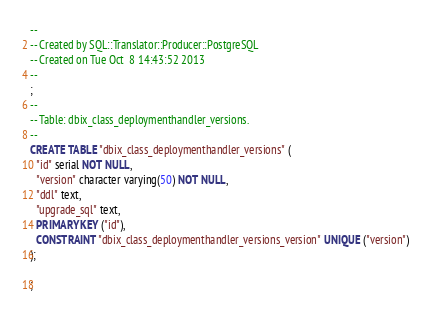<code> <loc_0><loc_0><loc_500><loc_500><_SQL_>-- 
-- Created by SQL::Translator::Producer::PostgreSQL
-- Created on Tue Oct  8 14:43:52 2013
-- 
;
--
-- Table: dbix_class_deploymenthandler_versions.
--
CREATE TABLE "dbix_class_deploymenthandler_versions" (
  "id" serial NOT NULL,
  "version" character varying(50) NOT NULL,
  "ddl" text,
  "upgrade_sql" text,
  PRIMARY KEY ("id"),
  CONSTRAINT "dbix_class_deploymenthandler_versions_version" UNIQUE ("version")
);

;
</code> 